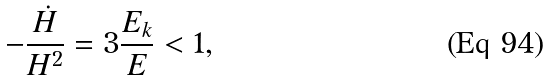<formula> <loc_0><loc_0><loc_500><loc_500>- \frac { \dot { H } } { H ^ { 2 } } = 3 \frac { E _ { k } } { E } < 1 ,</formula> 